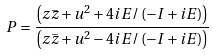Convert formula to latex. <formula><loc_0><loc_0><loc_500><loc_500>P = \frac { \left ( z \overset { \_ } { z } + u ^ { 2 } + 4 i E / \left ( - I + i E \right ) \right ) } { \left ( z \overset { \_ } { z } + u ^ { 2 } - 4 i E / \left ( - I + i E \right ) \right ) }</formula> 